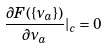Convert formula to latex. <formula><loc_0><loc_0><loc_500><loc_500>\frac { \partial F ( \{ \nu _ { a } \} ) } { \partial \nu _ { a } } | _ { c } = 0</formula> 